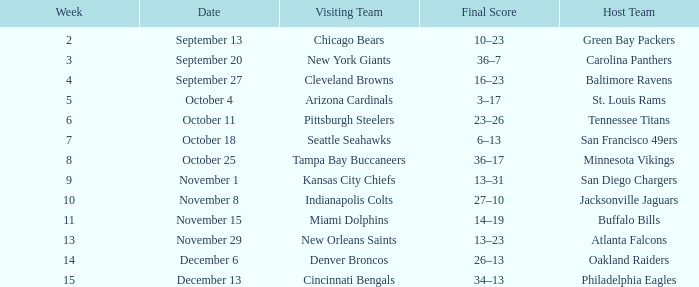What was the final score on week 14 ? 26–13. 